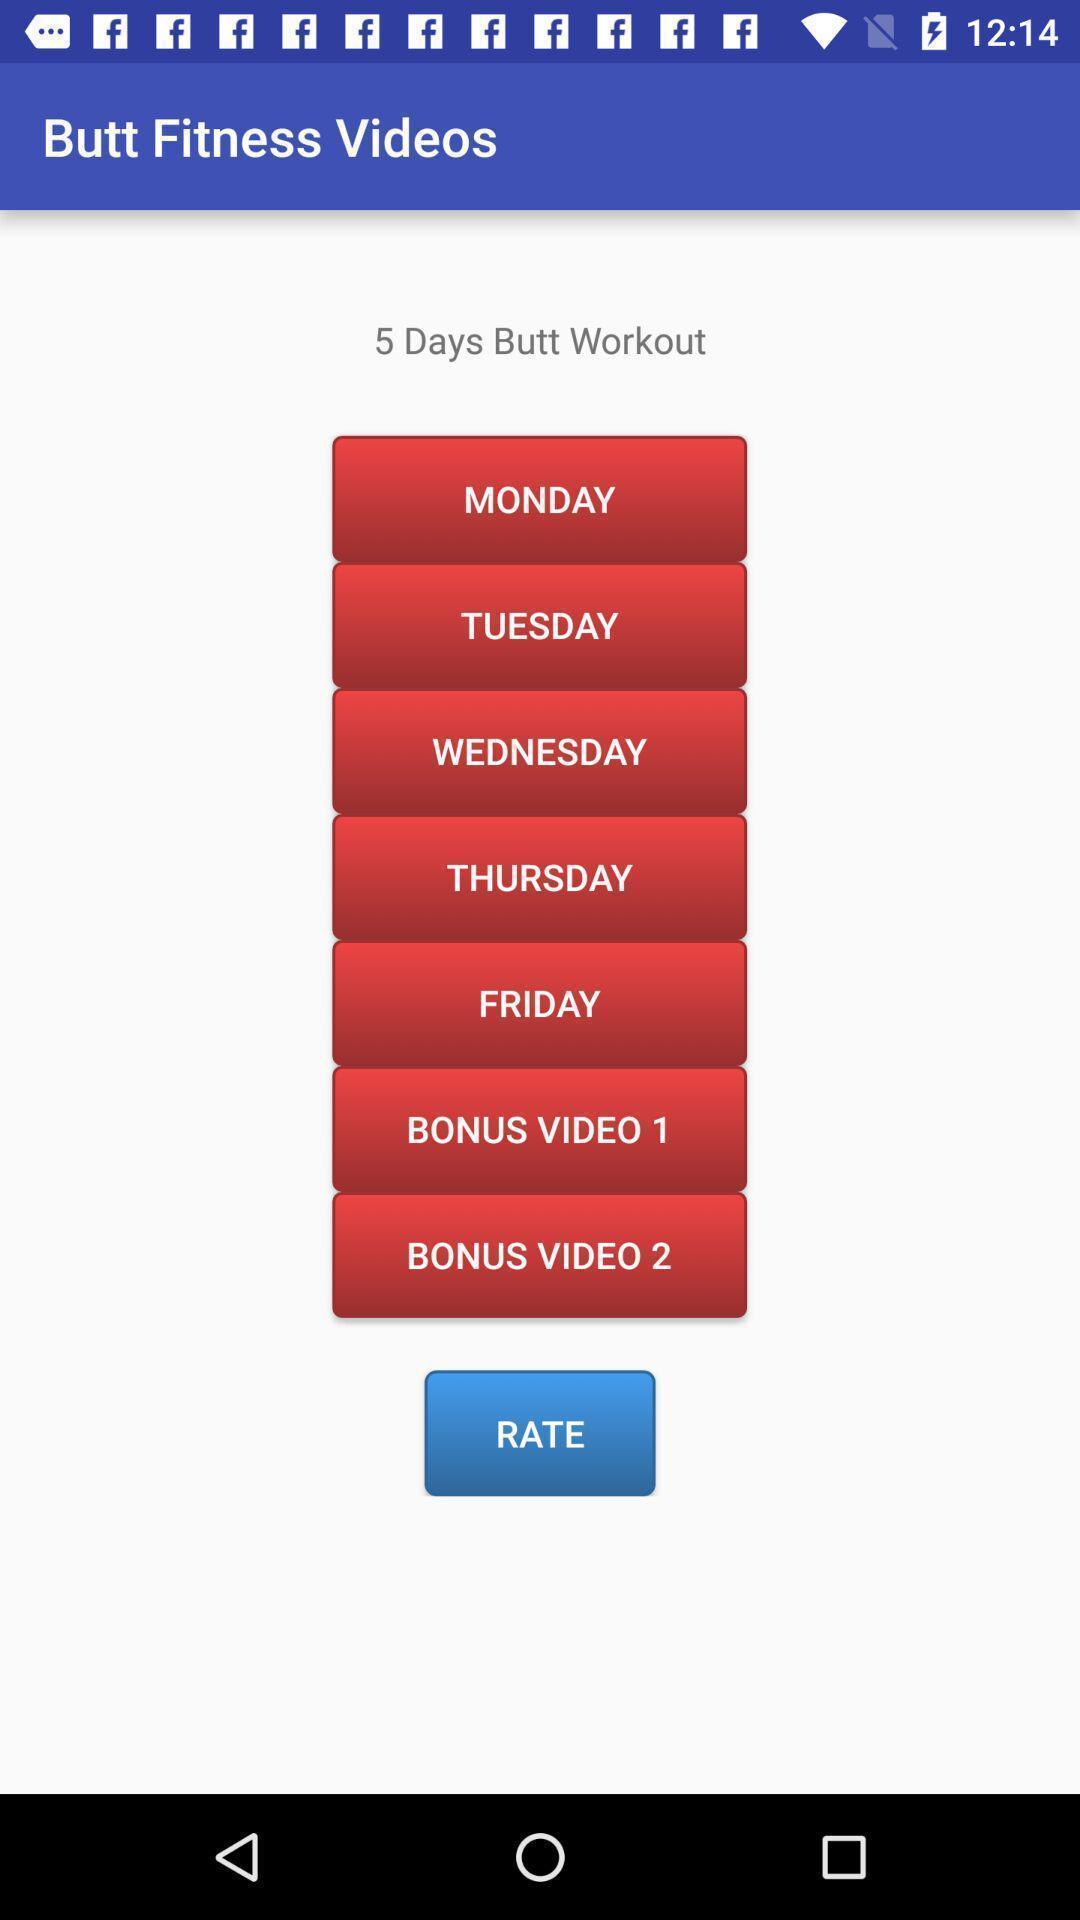Provide a description of this screenshot. Screen displaying the screen page of a fitness app. 